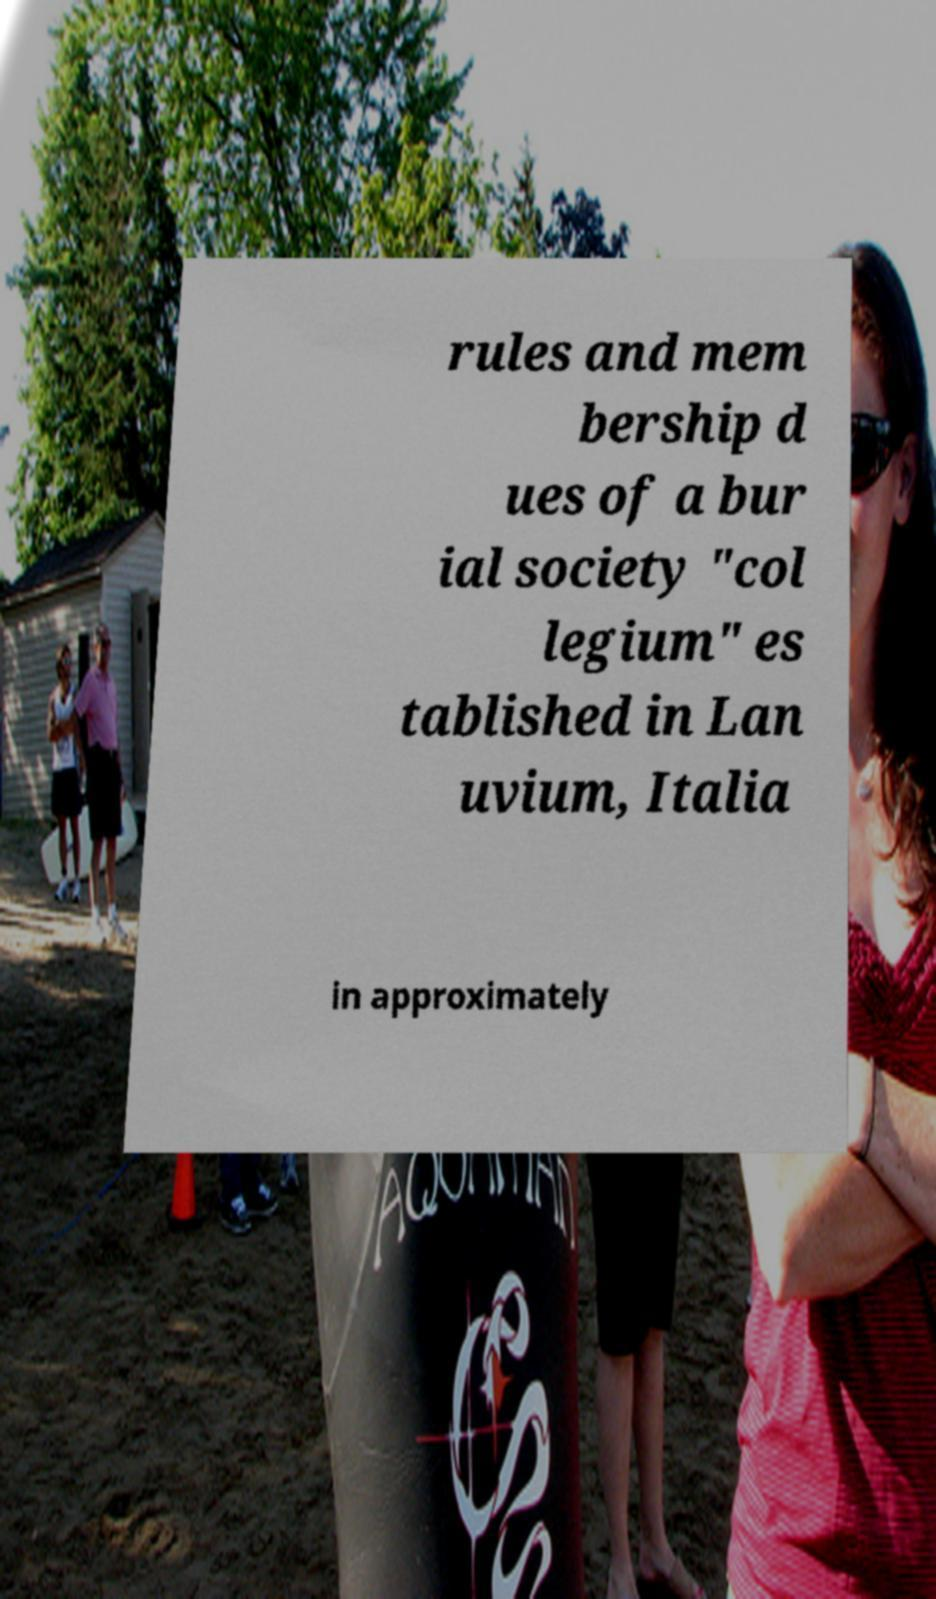Could you extract and type out the text from this image? rules and mem bership d ues of a bur ial society "col legium" es tablished in Lan uvium, Italia in approximately 